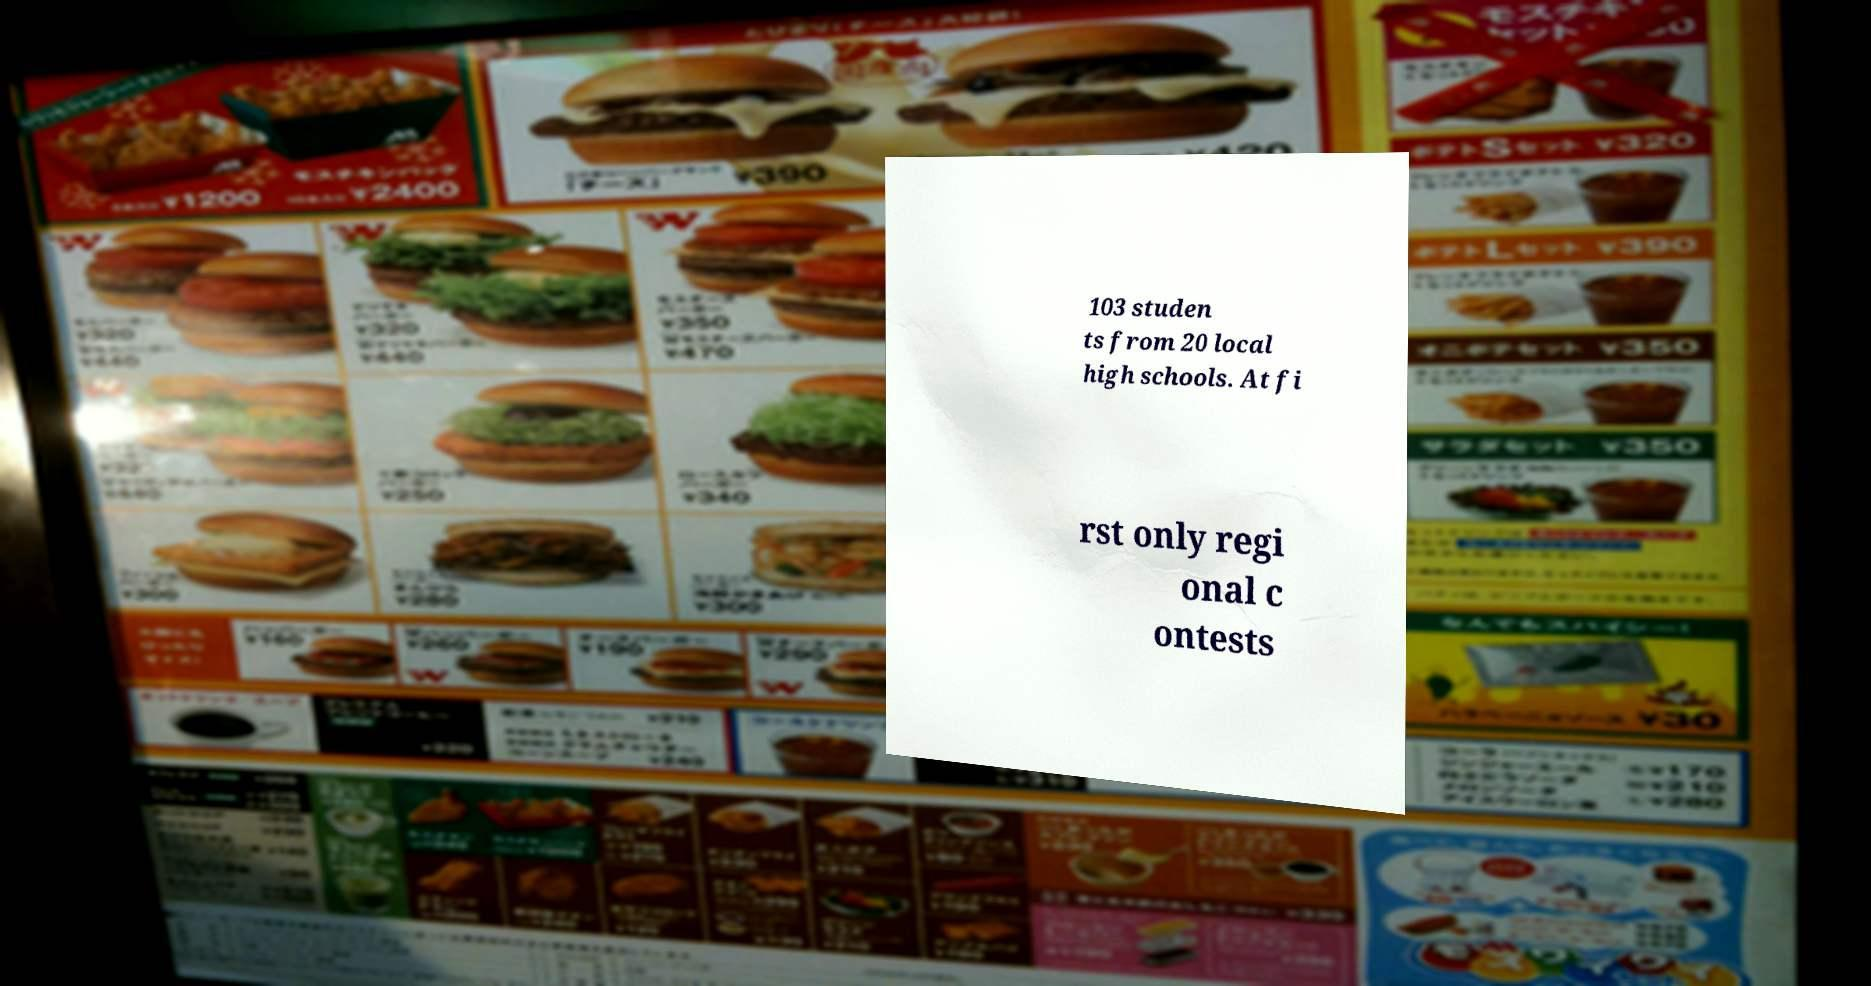Can you accurately transcribe the text from the provided image for me? 103 studen ts from 20 local high schools. At fi rst only regi onal c ontests 